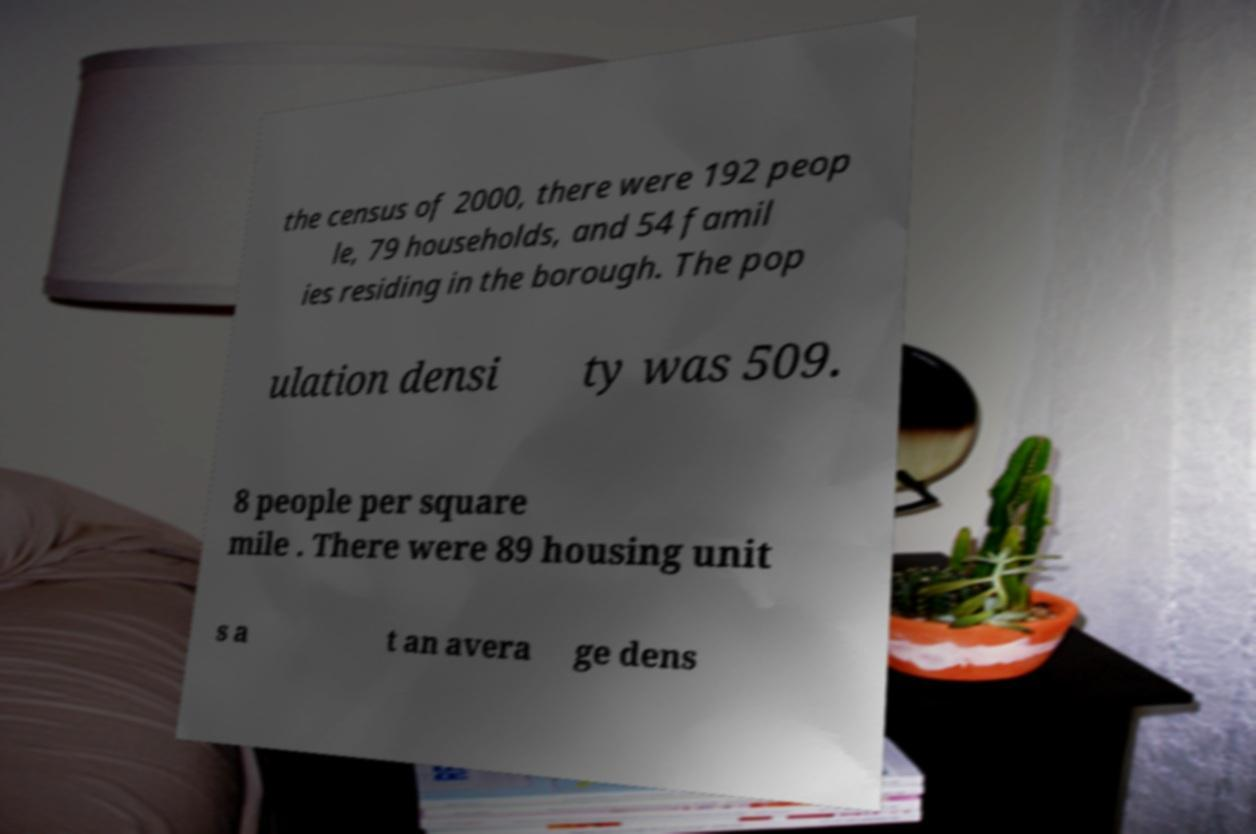What messages or text are displayed in this image? I need them in a readable, typed format. the census of 2000, there were 192 peop le, 79 households, and 54 famil ies residing in the borough. The pop ulation densi ty was 509. 8 people per square mile . There were 89 housing unit s a t an avera ge dens 